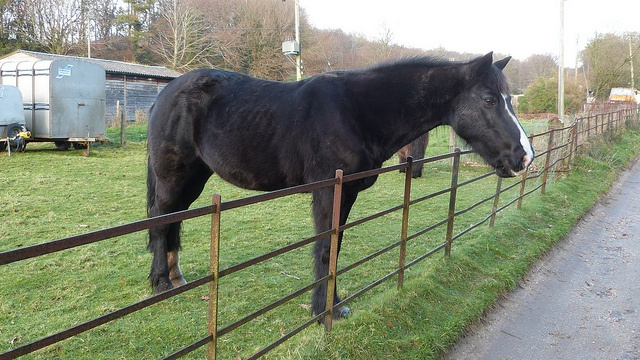Describe the objects in this image and their specific colors. I can see horse in olive, black, gray, and darkgray tones, truck in olive, darkgray, white, and lightblue tones, and truck in olive, lightblue, gray, lightgray, and darkgray tones in this image. 